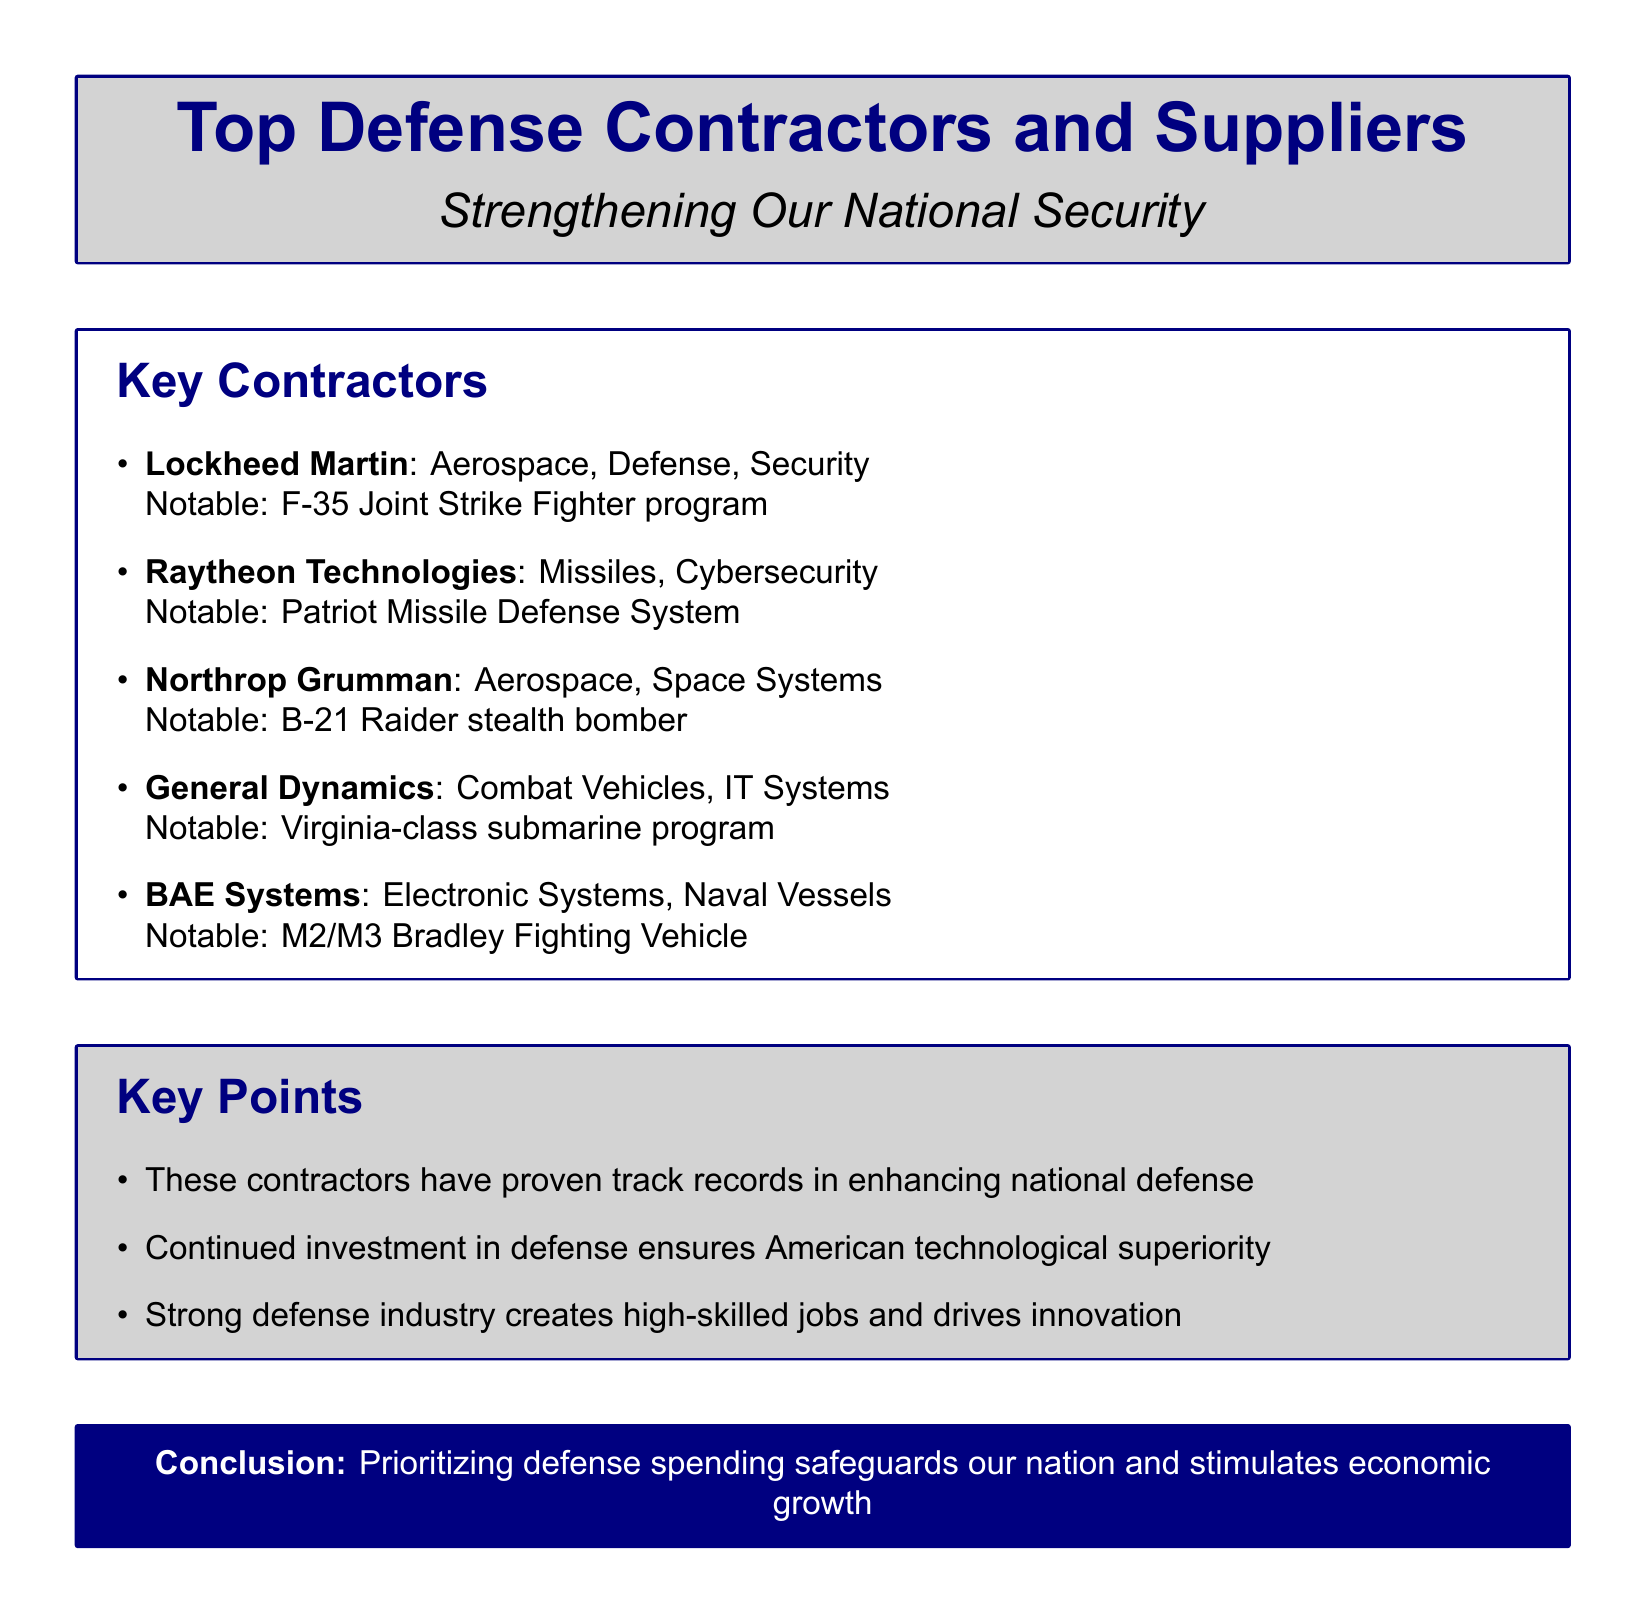What is the notable program for Lockheed Martin? The notable program for Lockheed Martin mentioned in the document is the F-35 Joint Strike Fighter program.
Answer: F-35 Joint Strike Fighter program What type of systems does Raytheon Technologies specialize in? Raytheon Technologies specializes in missiles and cybersecurity as stated in the document.
Answer: Missiles, Cybersecurity What is the notable product of Northrop Grumman? The notable product of Northrop Grumman mentioned is the B-21 Raider stealth bomber.
Answer: B-21 Raider stealth bomber How many contractors are listed in the document? There are five contractors listed in the document under the "Key Contractors" section.
Answer: Five What is the primary benefit of continued investment in defense according to the document? The primary benefit mentioned is that continued investment in defense ensures American technological superiority.
Answer: Technological superiority Which contractor is associated with naval vessels? BAE Systems is the contractor associated with naval vessels as mentioned in the document.
Answer: BAE Systems What type of vehicles does General Dynamics specialize in? General Dynamics specializes in combat vehicles as per the document's description.
Answer: Combat Vehicles What argument is made about the defense industry in the document? The document argues that a strong defense industry creates high-skilled jobs and drives innovation.
Answer: High-skilled jobs and innovation 